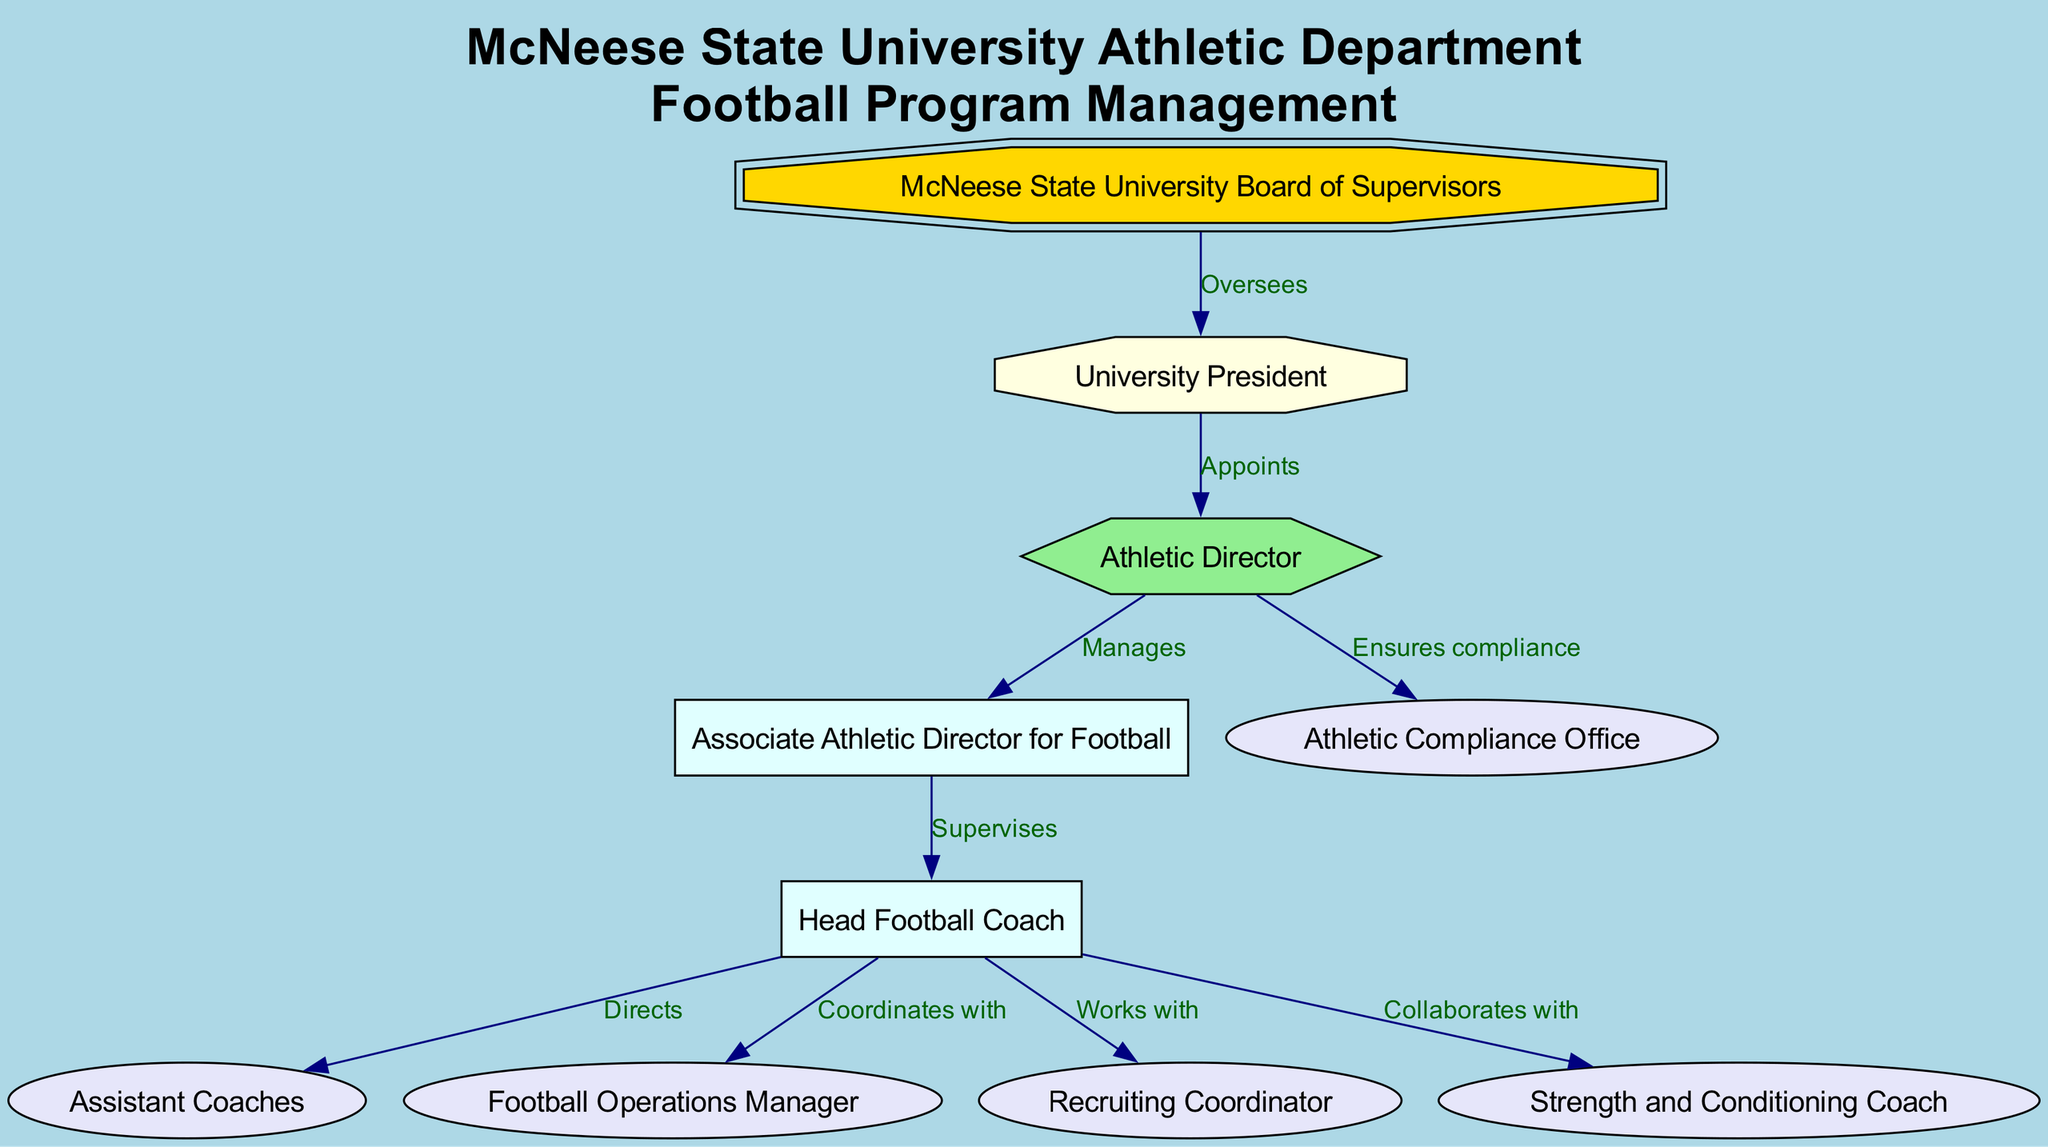What is the highest authority in the diagram? The highest authority is represented by the top node, which is the "McNeese State University Board of Supervisors." This is confirmed by looking for the node that has no incoming edges from any other node, indicating it is the starting point or highest level.
Answer: McNeese State University Board of Supervisors How many nodes are present in the diagram? To find the total number of nodes, we can count each of the distinct entities represented. There are ten nodes listed in the provided data, corresponding to various roles in the athletic department.
Answer: 10 What relationship does the Athletic Director have with the Associate Athletic Director for Football? The relationship indicated is that the Athletic Director "Manages" the Associate Athletic Director for Football. This is found by tracing the edge from the node representing Athletic Director to the node representing Associate Athletic Director for Football, with the label detailing their relationship.
Answer: Manages Who does the Head Football Coach direct? The Head Football Coach directs the "Assistant Coaches." This is determined by looking at the edges emanating from the Head Football Coach node; it specifically points to the Assistant Coaches with the "Directs" label.
Answer: Assistant Coaches How does the Head Football Coach interact with the Football Operations Manager? The interaction is noted as "Coordinates with." By tracing the edge from the Head Football Coach node to the Football Operations Manager node, the label describes their collaborative relationship as coordination rather than a supervisory or direct reporting one.
Answer: Coordinates with Which role is responsible for ensuring compliance? The role responsible is the "Athletic Compliance Office." By identifying the edge leading from the Athletic Director to this office, it's clear that the management's responsibility for compliance oversight falls under this node.
Answer: Athletic Compliance Office Which node has a supervisory role? The Associate Athletic Director for Football has a supervisory role as indicated by the edge that states "Supervises" with an arrow pointing towards the Head Football Coach. This relationship signifies a hierarchical connection where supervision is a key responsibility.
Answer: Supervises What is the relationship between the University President and the Athletic Director? The relationship is that the University President "Appoints" the Athletic Director. This is clear from the edge connecting these two nodes, with the label specifying the action taken by the University President regarding the appointment.
Answer: Appoints How many collaborations does the Head Football Coach have listed in the diagram? The Head Football Coach has three collaborations listed: with Assistant Coaches, Football Operations Manager, and Strength and Conditioning Coach. Counting these edges leads to a total of three collaboration instances annotated on the graph.
Answer: 3 What shape is used for the University President in the diagram? The University President is represented by an "octagon." This shape is specifically mentioned in the code where nodes are defined, particularly identifying different roles with corresponding shapes.
Answer: Octagon 